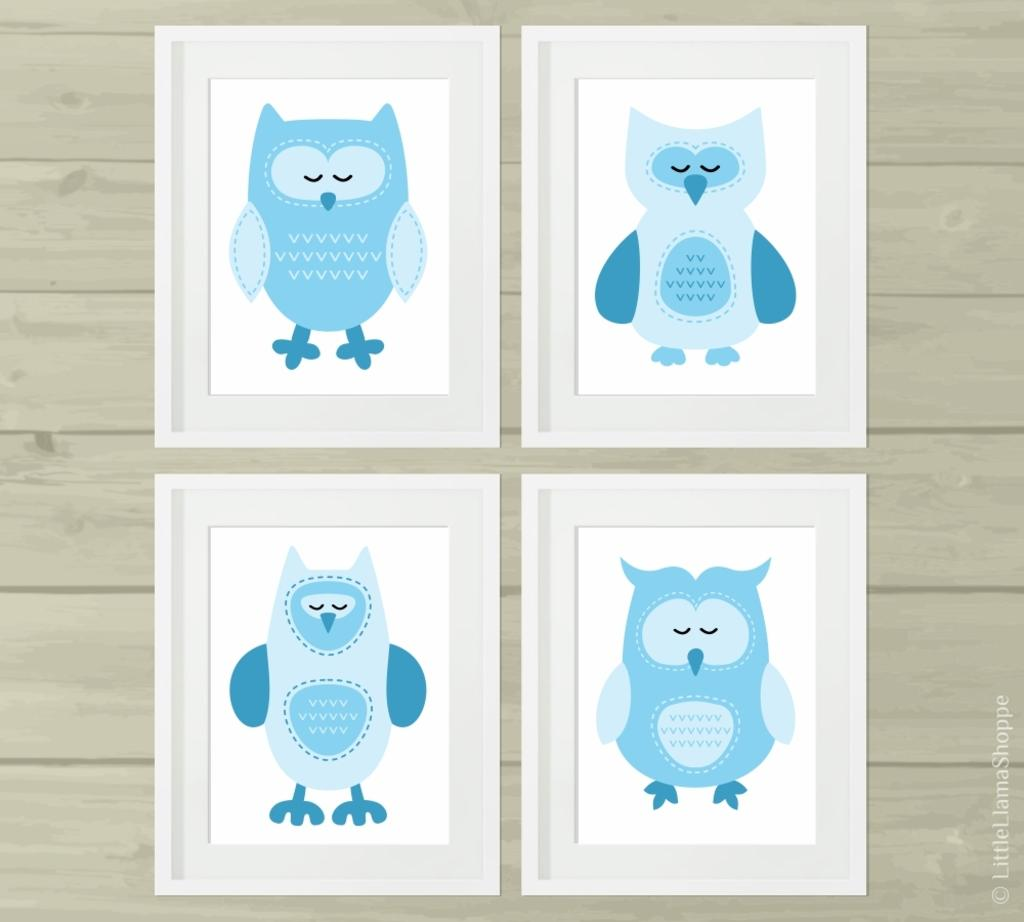How many cards are present in the image? There are four cards in the image. What is depicted on the cards? The cards have pictures of cartoons on them. Can you see a frog hopping on the sea in the image? There is no frog or sea present in the image; it features four cards with pictures of cartoons on them. 